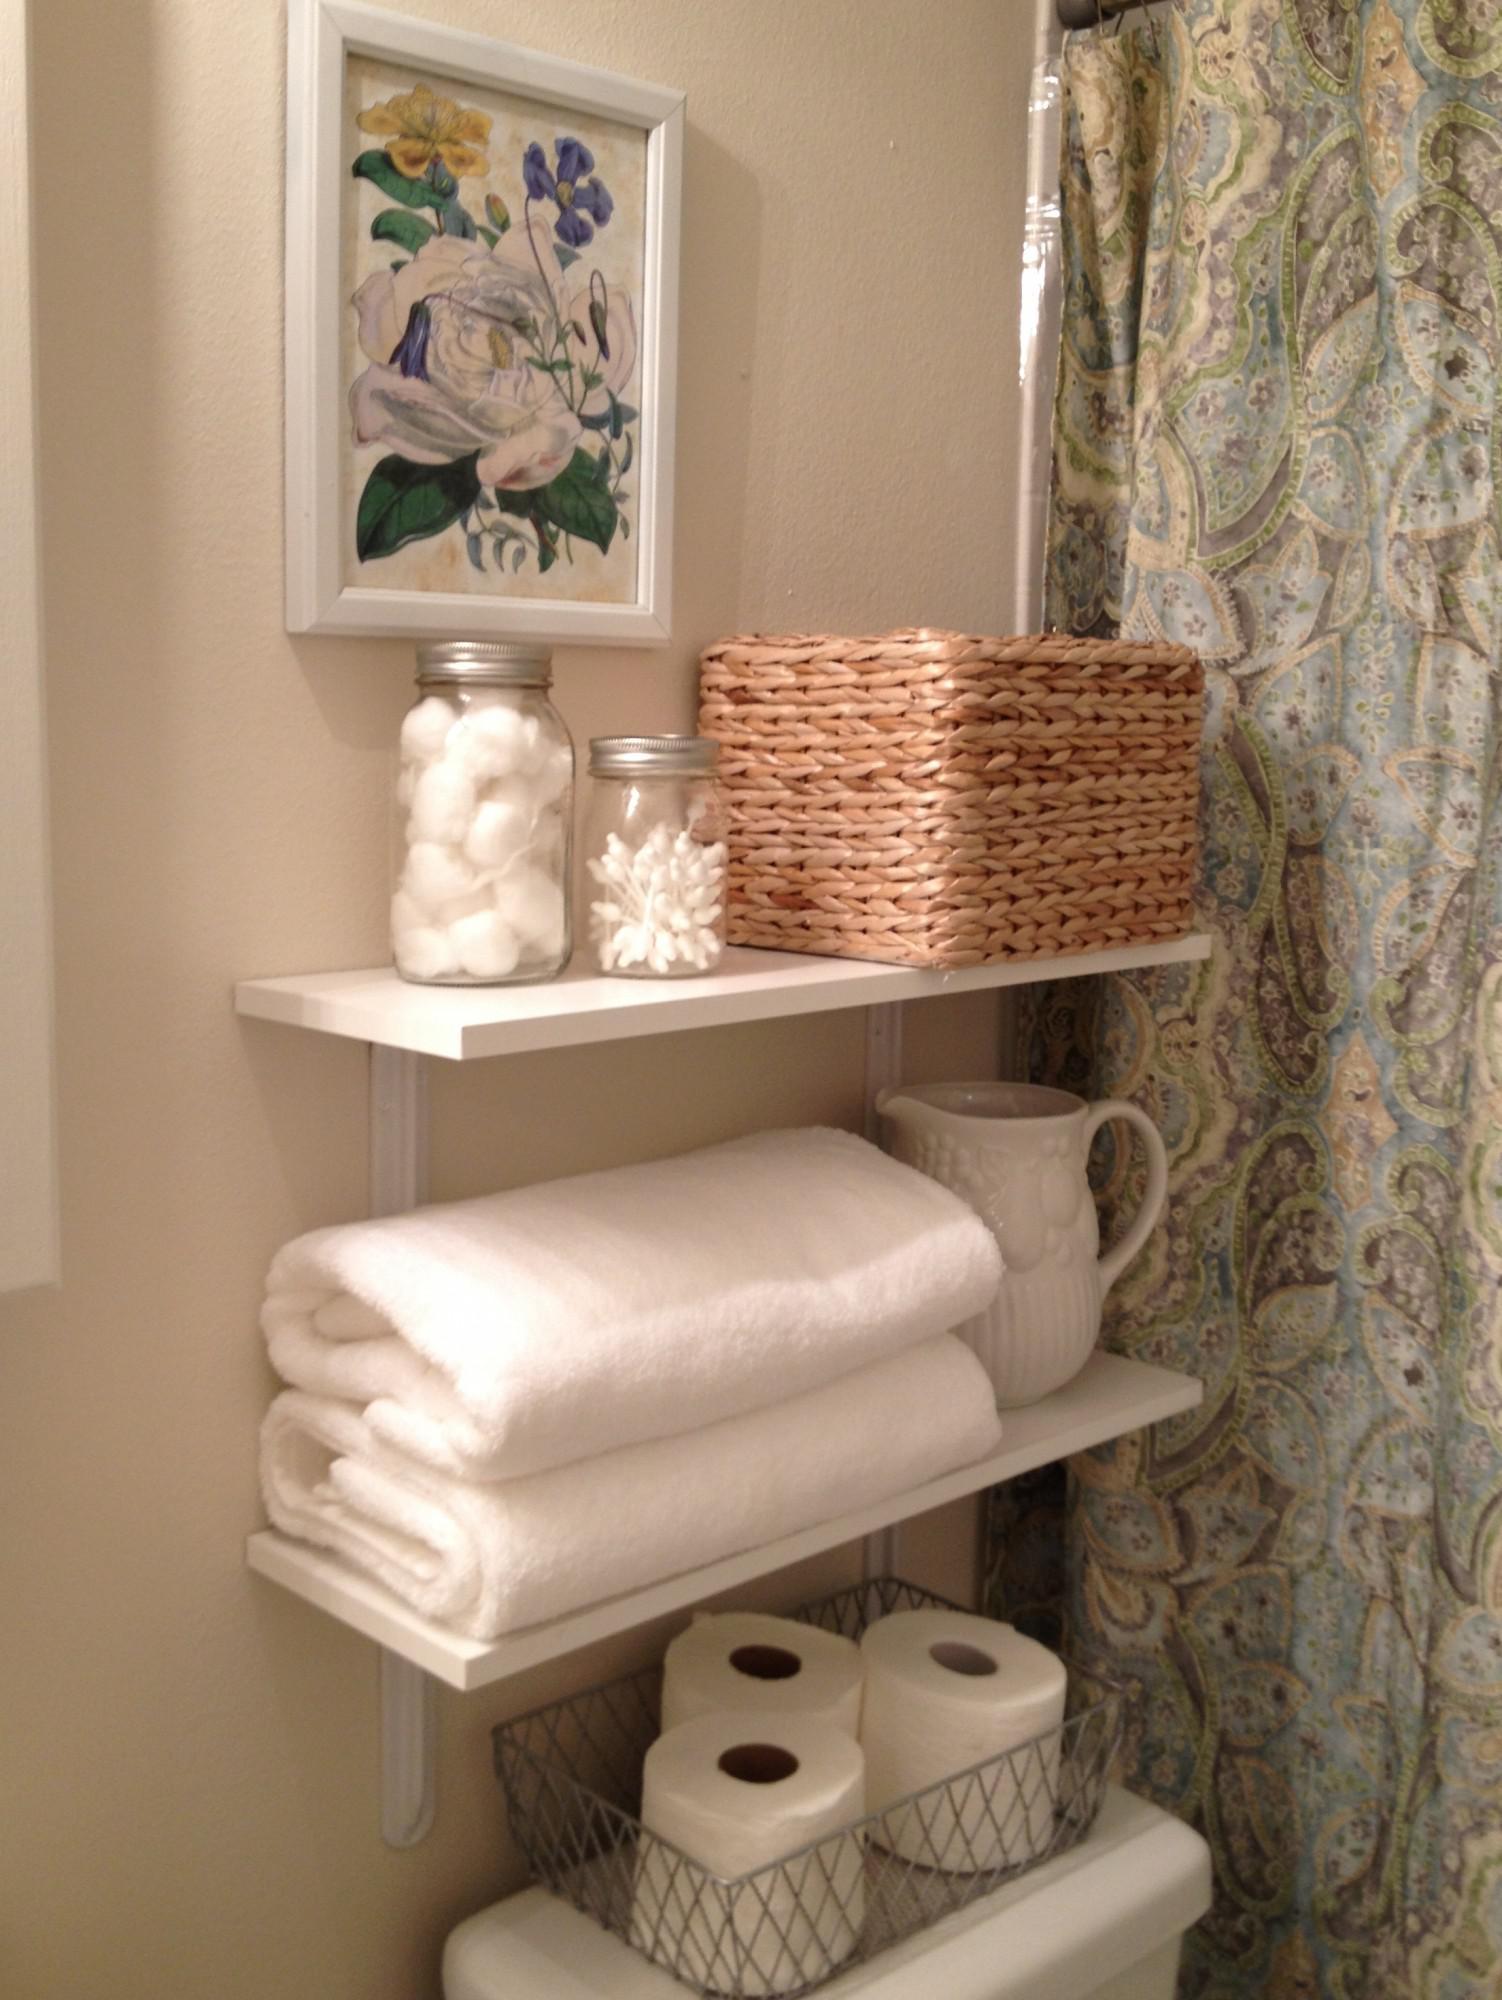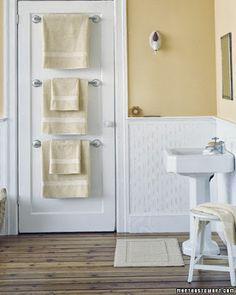The first image is the image on the left, the second image is the image on the right. Considering the images on both sides, is "In one image, a white pedestal sink stands against a wall." valid? Answer yes or no. Yes. The first image is the image on the left, the second image is the image on the right. Examine the images to the left and right. Is the description "There are at least two mirrors visible hanging on the walls." accurate? Answer yes or no. No. 